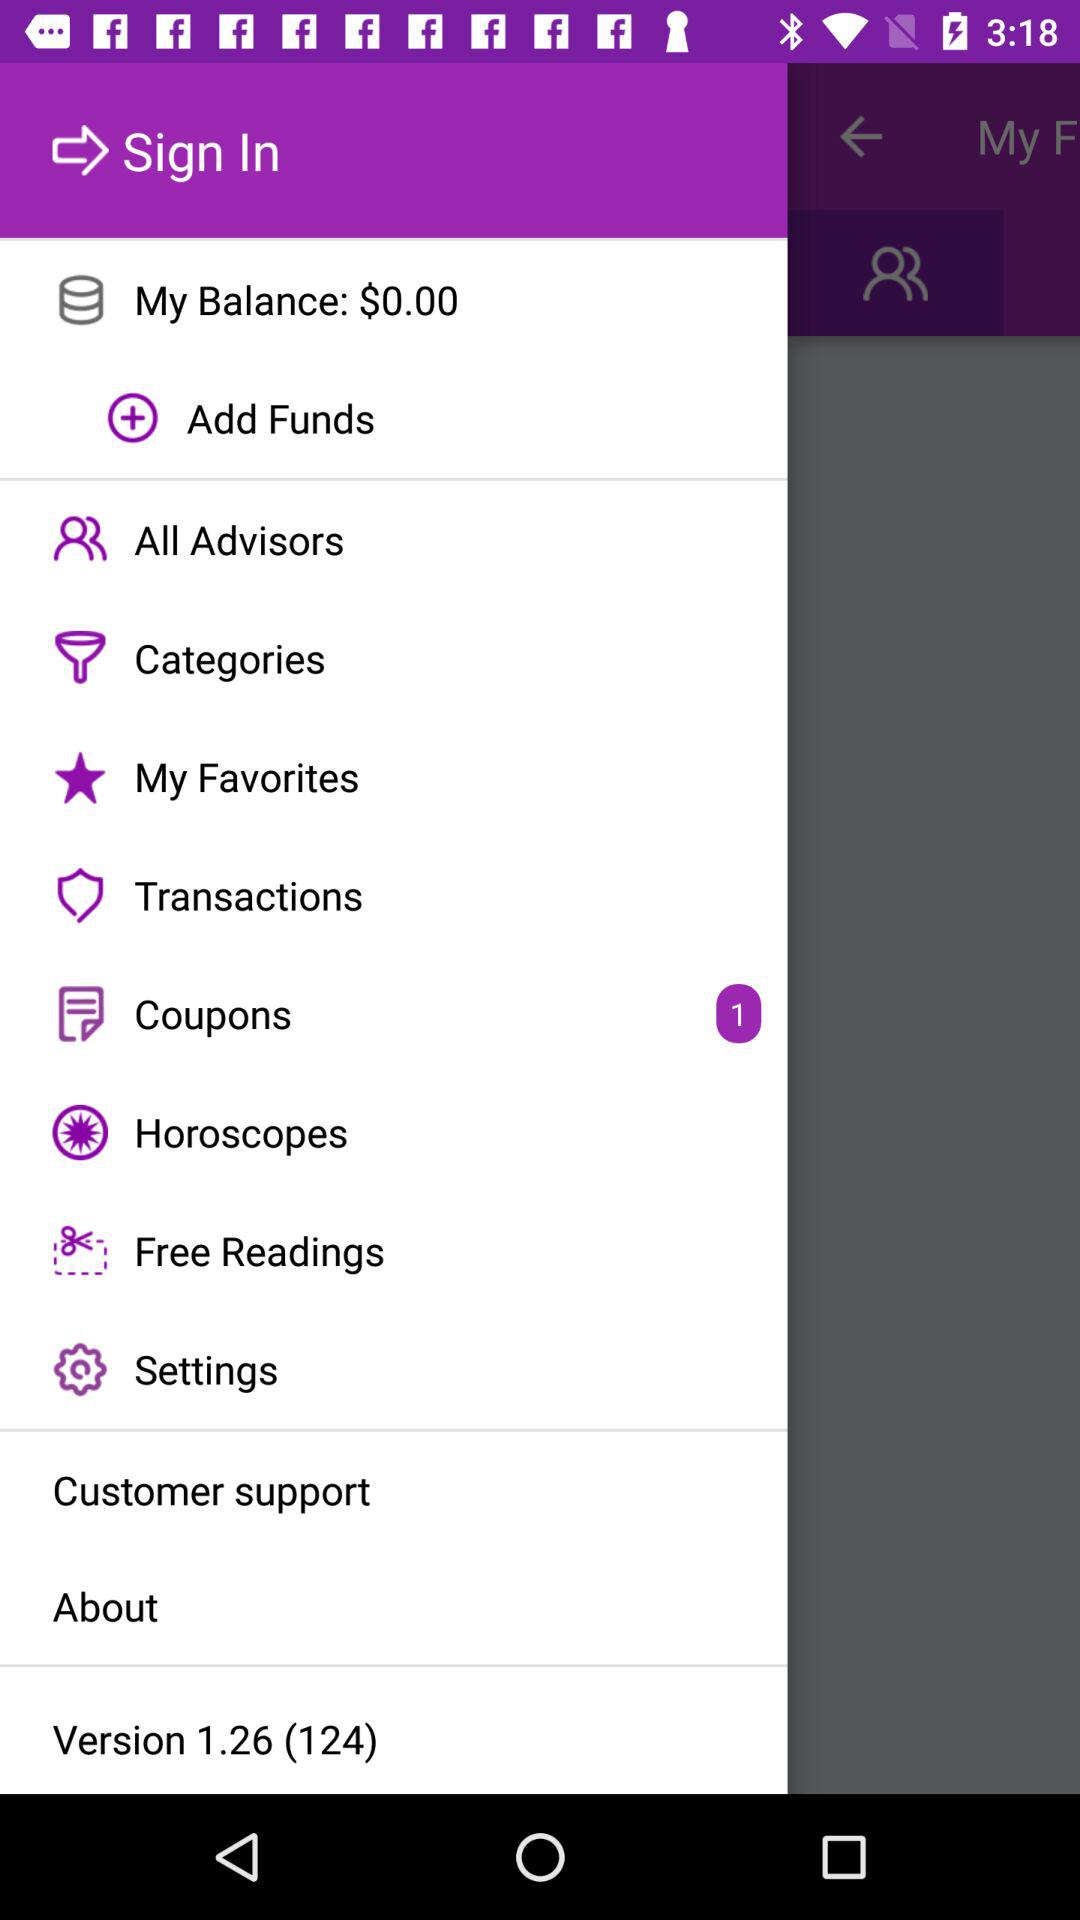How many coupons are there? There is 1 coupon. 